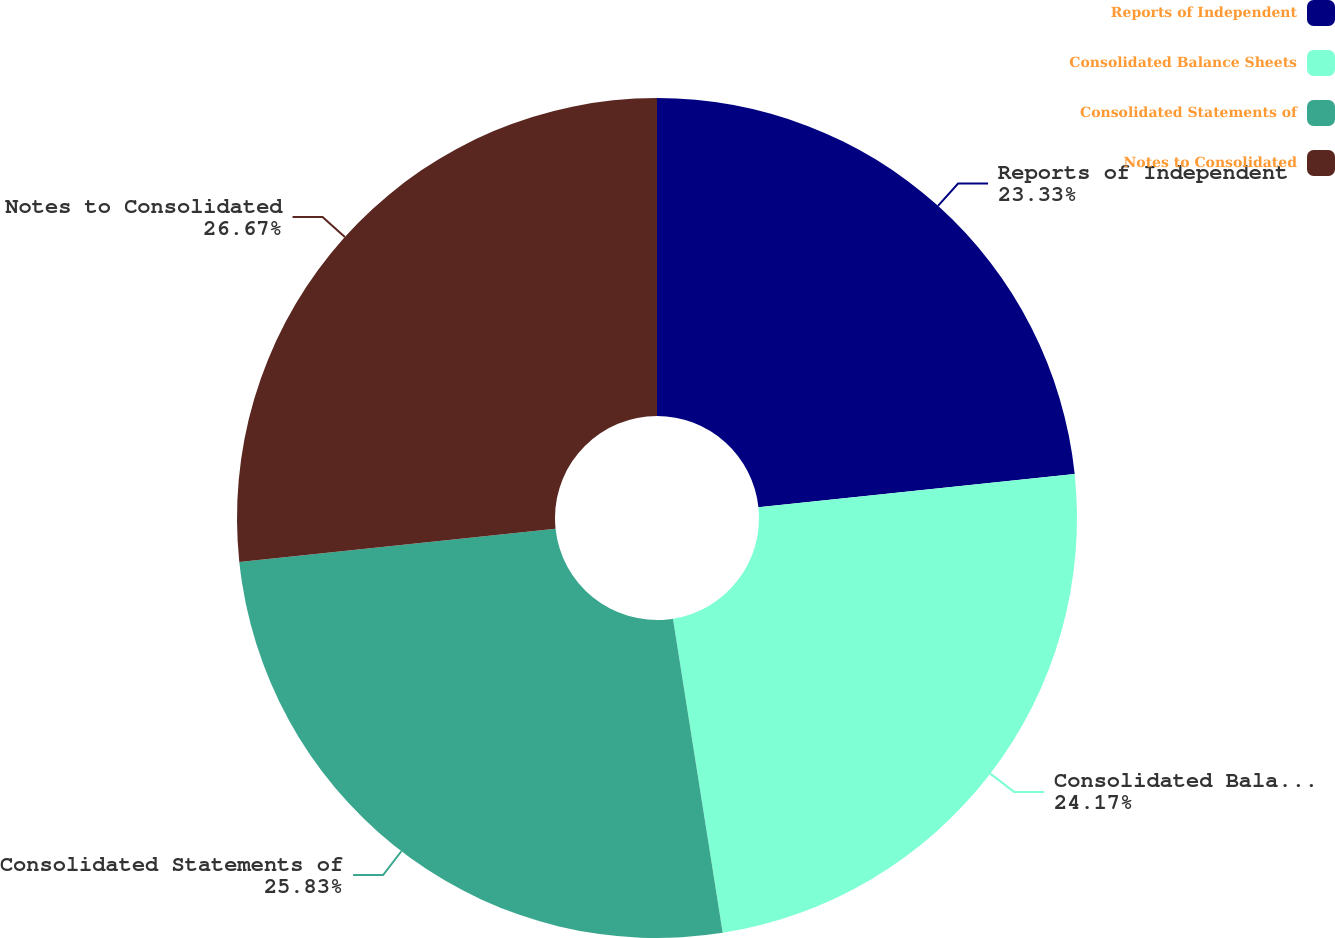Convert chart. <chart><loc_0><loc_0><loc_500><loc_500><pie_chart><fcel>Reports of Independent<fcel>Consolidated Balance Sheets<fcel>Consolidated Statements of<fcel>Notes to Consolidated<nl><fcel>23.33%<fcel>24.17%<fcel>25.83%<fcel>26.67%<nl></chart> 